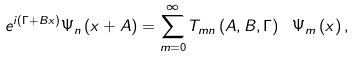Convert formula to latex. <formula><loc_0><loc_0><loc_500><loc_500>e ^ { i \left ( \Gamma + B x \right ) } \Psi _ { n } \left ( x + A \right ) = \sum _ { m = 0 } ^ { \infty } T _ { m n } \left ( A , B , \Gamma \right ) \ \Psi _ { m } \left ( x \right ) ,</formula> 